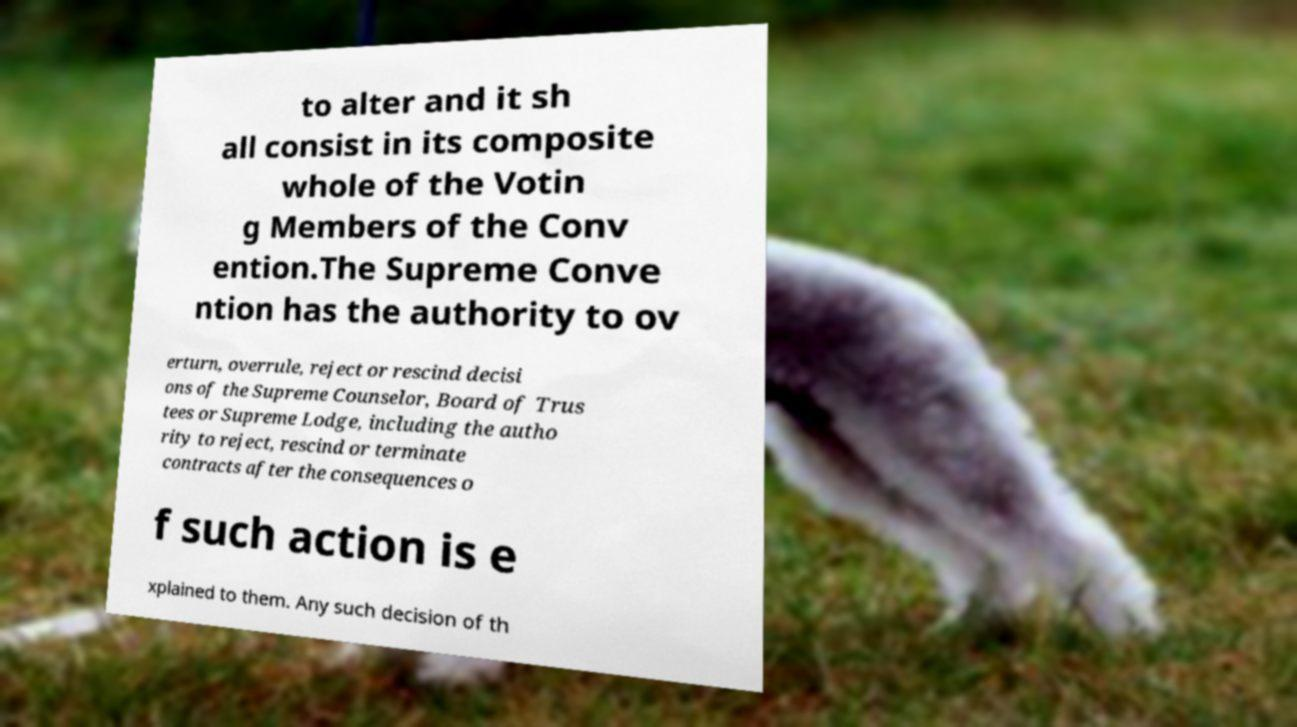Can you accurately transcribe the text from the provided image for me? to alter and it sh all consist in its composite whole of the Votin g Members of the Conv ention.The Supreme Conve ntion has the authority to ov erturn, overrule, reject or rescind decisi ons of the Supreme Counselor, Board of Trus tees or Supreme Lodge, including the autho rity to reject, rescind or terminate contracts after the consequences o f such action is e xplained to them. Any such decision of th 